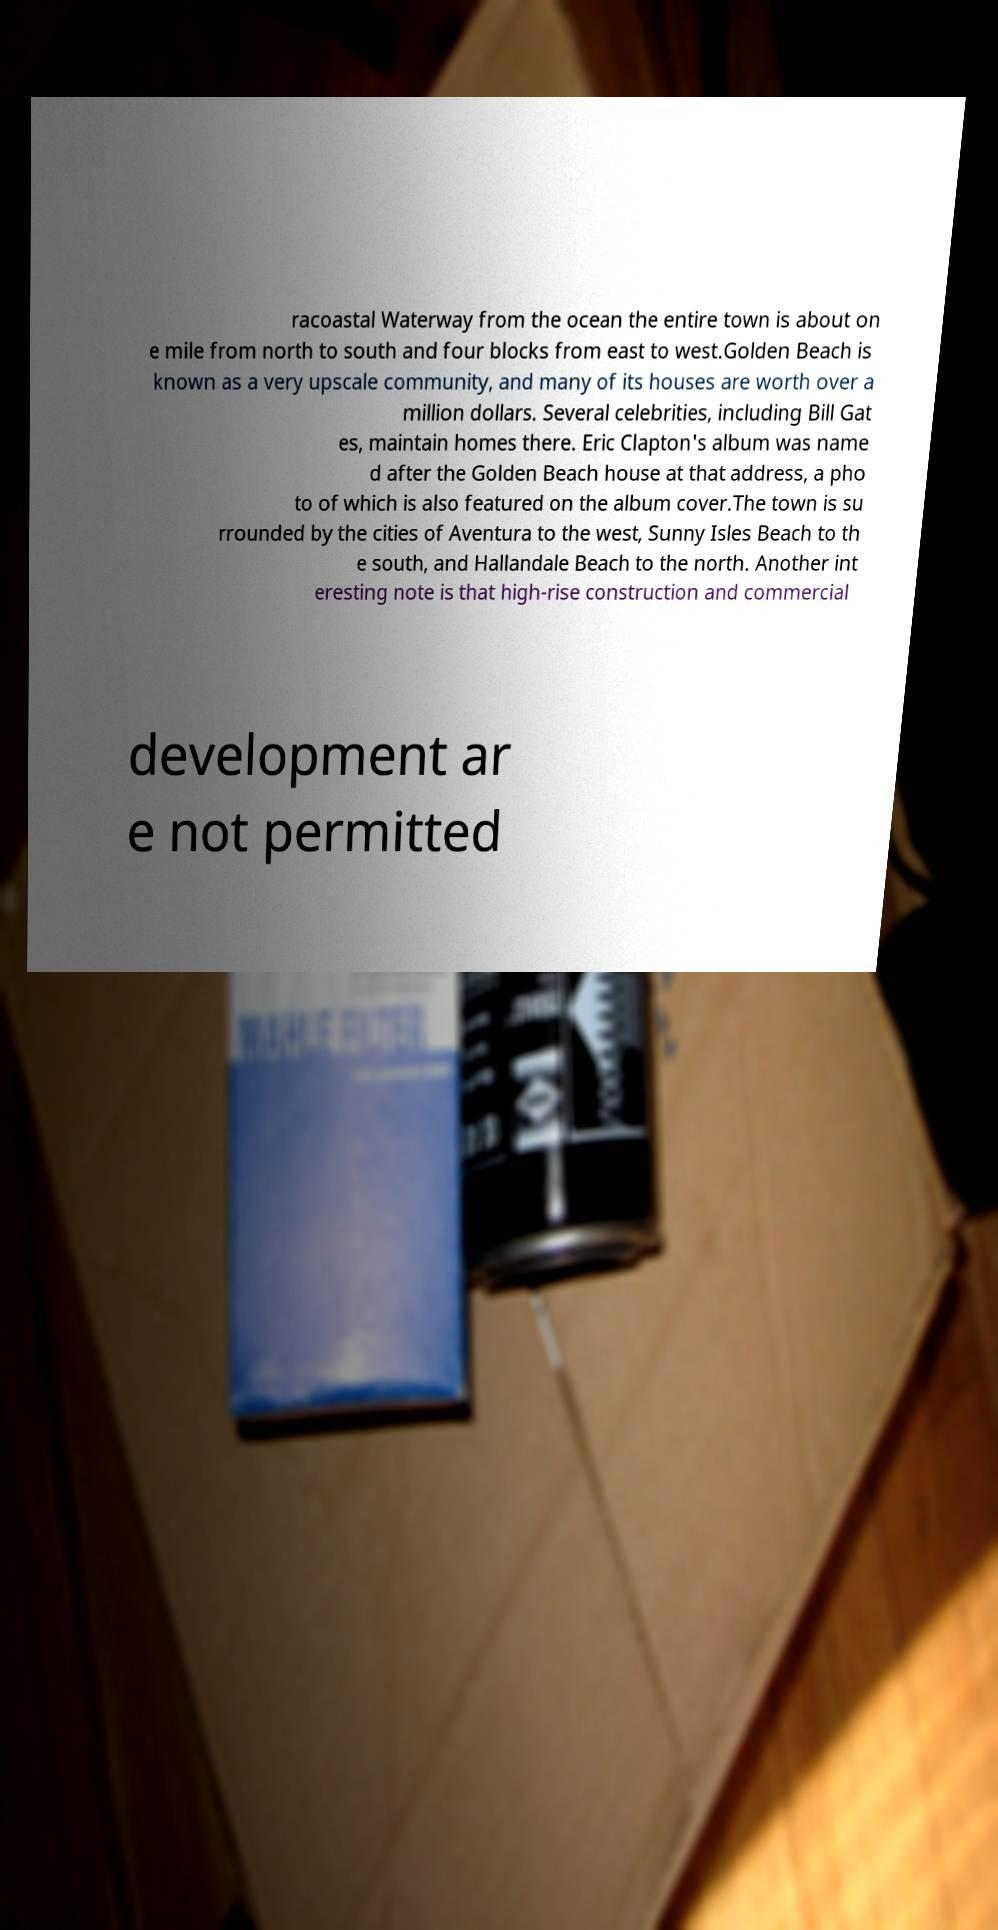Please read and relay the text visible in this image. What does it say? racoastal Waterway from the ocean the entire town is about on e mile from north to south and four blocks from east to west.Golden Beach is known as a very upscale community, and many of its houses are worth over a million dollars. Several celebrities, including Bill Gat es, maintain homes there. Eric Clapton's album was name d after the Golden Beach house at that address, a pho to of which is also featured on the album cover.The town is su rrounded by the cities of Aventura to the west, Sunny Isles Beach to th e south, and Hallandale Beach to the north. Another int eresting note is that high-rise construction and commercial development ar e not permitted 